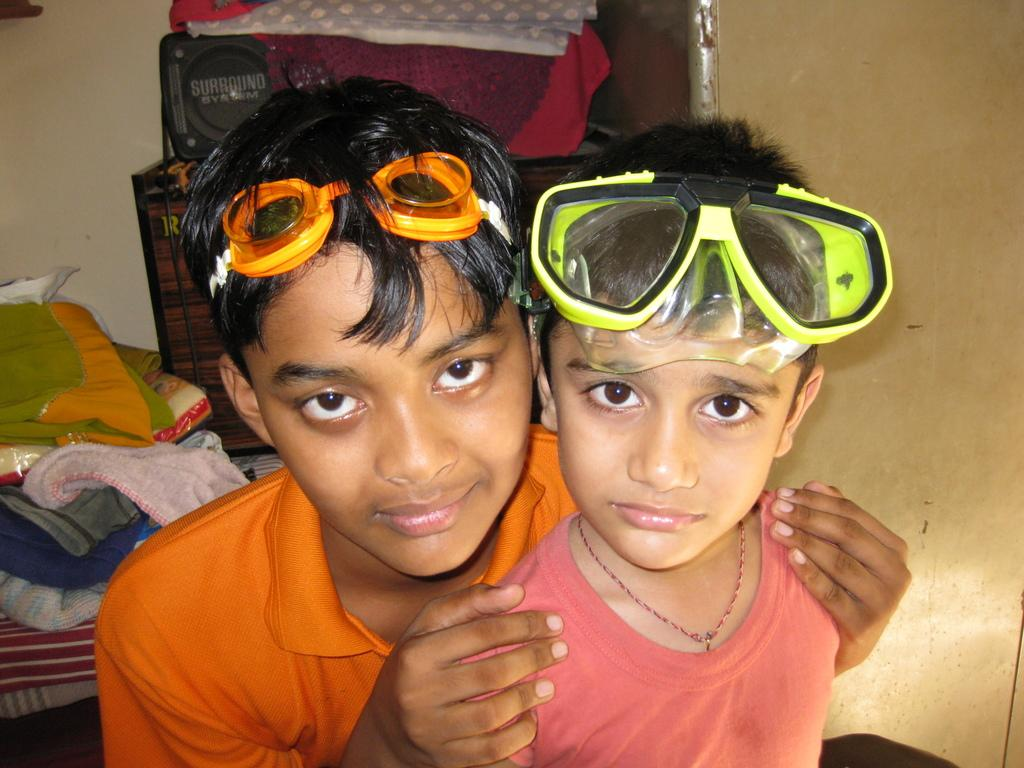How many people are in the image? There are two people in the image. What colors are the dresses worn by the people? One person is wearing a red dress, and the other person is wearing an orange dress. What accessory do both people have in common? Both people are wearing glasses. What can be seen in the background of the image? There are clothes and objects visible in the background, as well as a wall. What type of parcel is being delivered by the person in the red dress? There is no parcel visible in the image, and the person in the red dress is not delivering anything. What kind of vessel is being used by the person in the orange dress? There is no vessel present in the image, and the person in the orange dress is not using any vessel. 